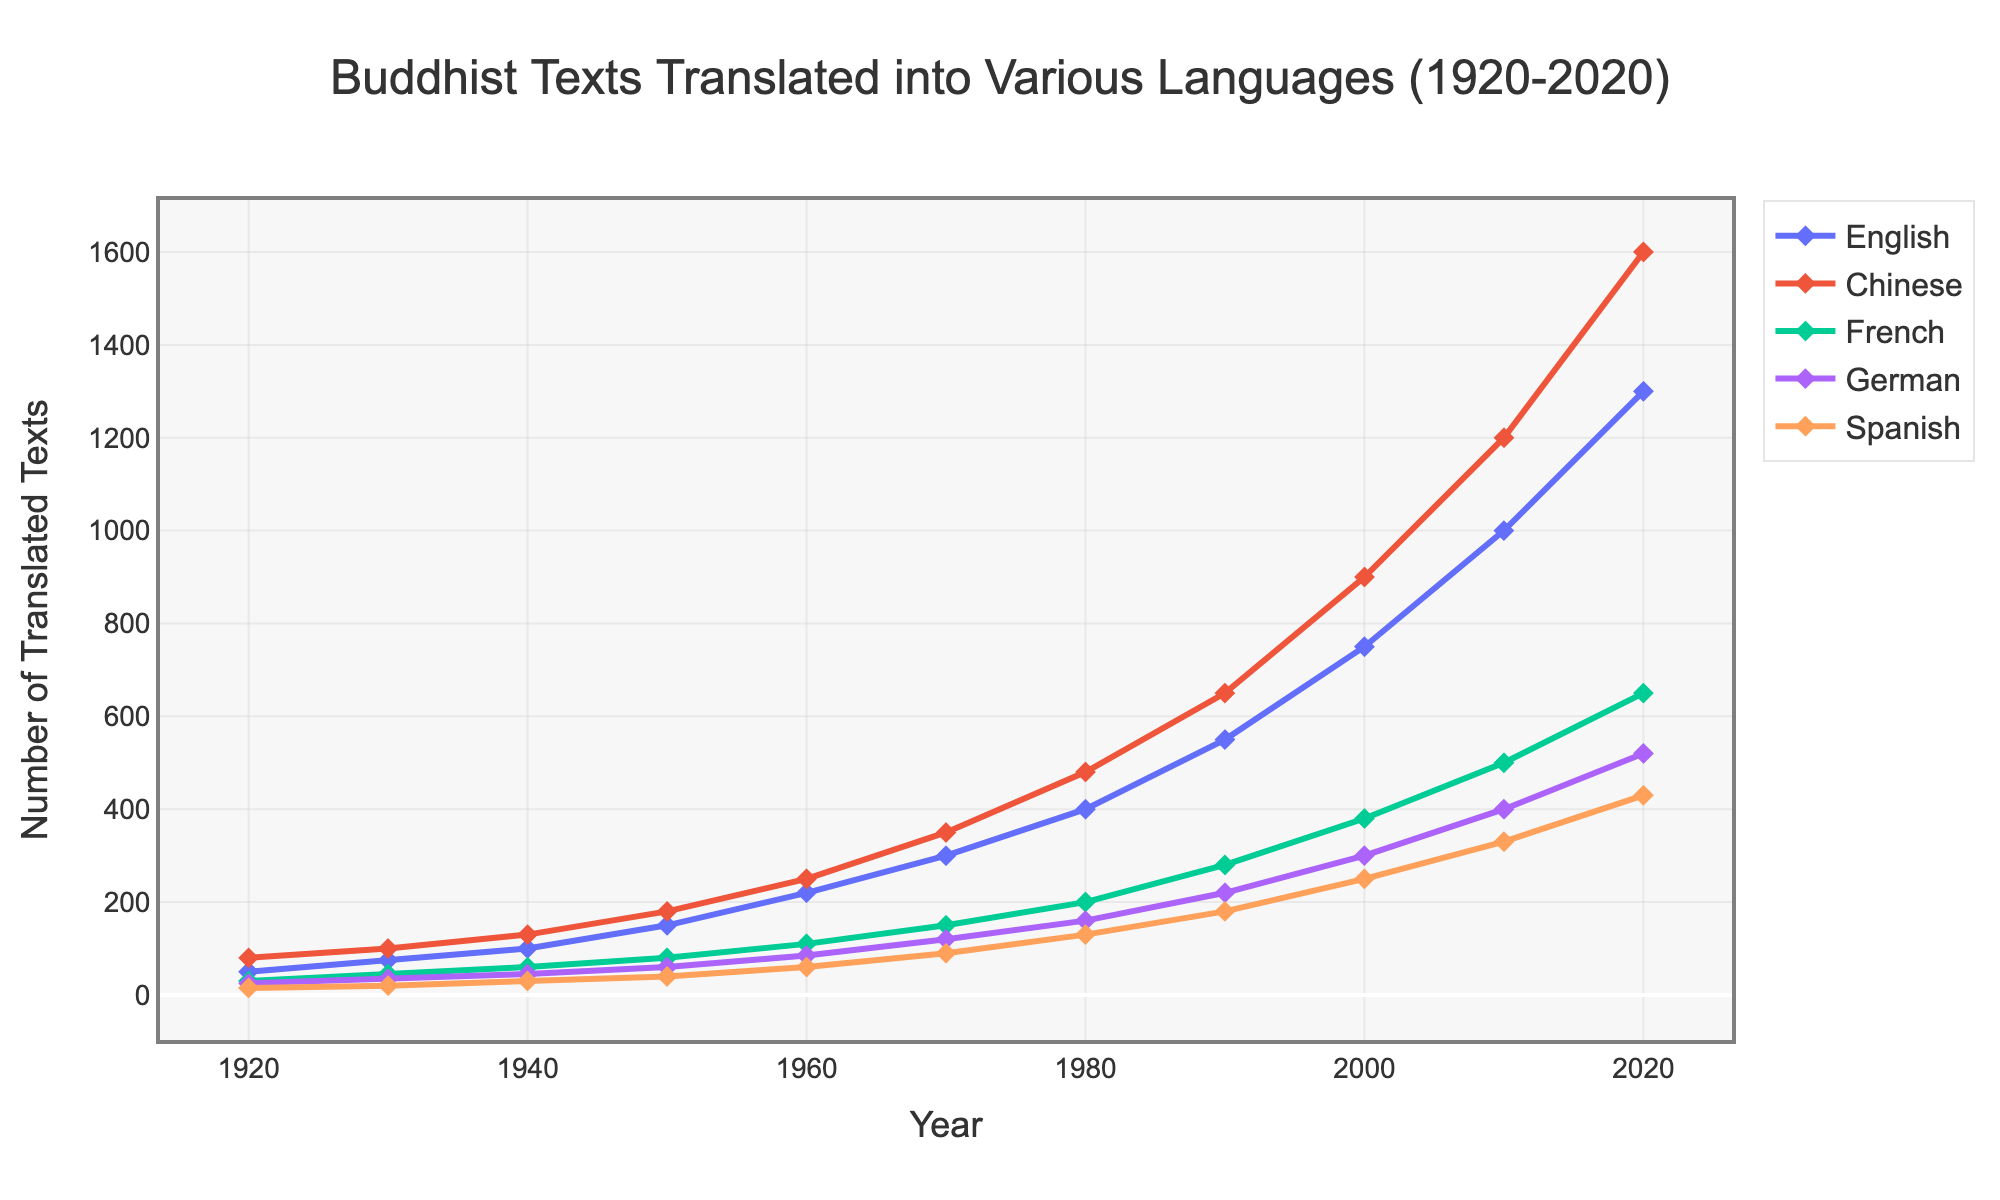How many texts were translated into Chinese in 1940 compared to English? First, find the number of texts translated into Chinese in 1940 (130) and English in 1940 (100). Compare the two values to see that the number translated into Chinese is higher.
Answer: Chinese is 130 and English is 100 Which language saw the highest increase in translated texts between 1920 and 2020? Calculate the difference in number of texts translated in each language between 1920 and 2020: English (1300-50), Chinese (1600-80), French (650-30), German (520-25), and Spanish (430-15). Compare these increases.
Answer: Chinese What was the average number of texts translated into German between 1920 and 2020? Sum the number of texts translated into German for all years and divide by the number of data points (11). Calculation: (25+35+45+60+85+120+160+220+300+400+520) / 11.
Answer: 180 Comparing the years 1950 and 2020, how many more texts were translated into Spanish in 2020? Subtract the number of texts translated into Spanish in 1950 from the number translated in 2020: 430 - 40 = 390.
Answer: 390 In which year did French translations surpass 400 texts for the first time? Analyze the data for French translations in each year and identify the first year that surpasses 400. The year is 2010.
Answer: 2010 Which language had the least number of translated texts in 2010? Refer to the data for 2010 and compare the number of translated texts in each language. Spanish had the least with 330 texts.
Answer: Spanish What is the total number of texts translated into English between 1920 and 1980? Add up the number of texts translated into English for the years 1920, 1930, 1940, 1950, 1960, 1970, and 1980: 50+75+100+150+220+300+400
Answer: 1295 